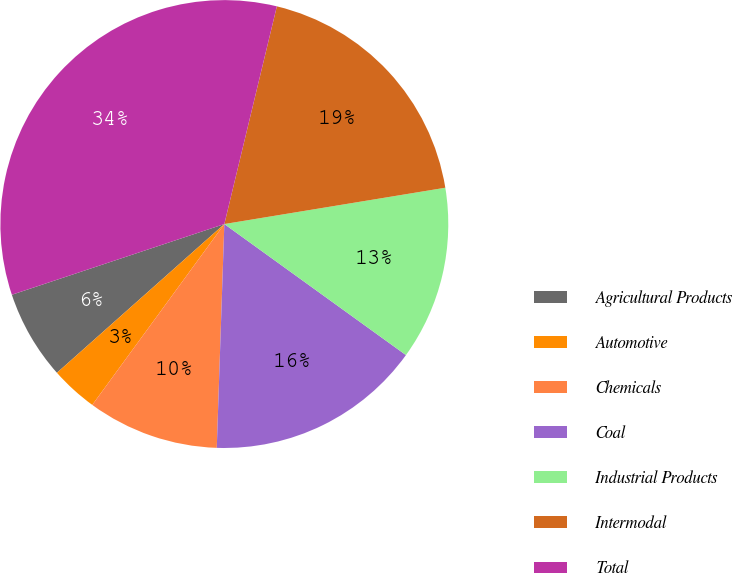Convert chart. <chart><loc_0><loc_0><loc_500><loc_500><pie_chart><fcel>Agricultural Products<fcel>Automotive<fcel>Chemicals<fcel>Coal<fcel>Industrial Products<fcel>Intermodal<fcel>Total<nl><fcel>6.45%<fcel>3.4%<fcel>9.5%<fcel>15.59%<fcel>12.54%<fcel>18.64%<fcel>33.88%<nl></chart> 